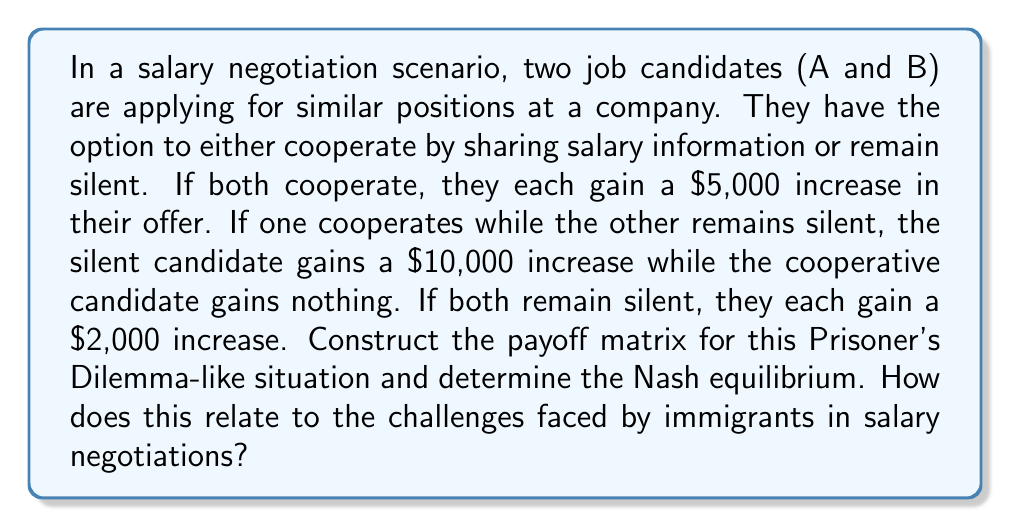Could you help me with this problem? To solve this problem, we need to follow these steps:

1. Construct the payoff matrix:
Let's create a 2x2 matrix representing the outcomes for both candidates:

$$
\begin{array}{c|c|c}
 & \text{B Cooperates} & \text{B Silent} \\
\hline
\text{A Cooperates} & (5000, 5000) & (0, 10000) \\
\hline
\text{A Silent} & (10000, 0) & (2000, 2000)
\end{array}
$$

2. Analyze the matrix to find the Nash equilibrium:
A Nash equilibrium occurs when neither player can unilaterally improve their outcome by changing their strategy.

For Candidate A:
- If B cooperates, A is better off being silent (10000 > 5000)
- If B is silent, A is better off being silent (2000 > 0)

For Candidate B:
- If A cooperates, B is better off being silent (10000 > 5000)
- If A is silent, B is better off being silent (2000 > 0)

Therefore, the Nash equilibrium is (A Silent, B Silent), resulting in both candidates gaining a $2,000 increase.

3. Relating to immigrant challenges in salary negotiations:
This scenario illustrates the difficulties immigrants might face in salary negotiations. The Nash equilibrium shows that individual self-interest leads to a suboptimal outcome for both parties. Immigrants, who may lack information about local salary standards or fear jeopardizing their job prospects, might be more likely to remain "silent" in negotiations. This can result in lower overall salary increases compared to what could be achieved through cooperation and information sharing.

As a retired executive helping immigrants with job search and interview skills, understanding this dynamic is crucial. It highlights the importance of encouraging immigrants to:
a) Research salary information thoroughly
b) Network with peers in their industry
c) Develop confidence in negotiation skills
d) Understand the value of transparency and cooperation in certain situations

By addressing these aspects, immigrants can be better equipped to navigate salary negotiations and potentially achieve more favorable outcomes.
Answer: The Nash equilibrium for this salary negotiation scenario is (A Silent, B Silent), resulting in both candidates gaining a $2,000 increase. This suboptimal outcome demonstrates the challenges immigrants may face in salary negotiations due to information asymmetry and the tendency to prioritize individual interests over potential mutual benefits from cooperation. 